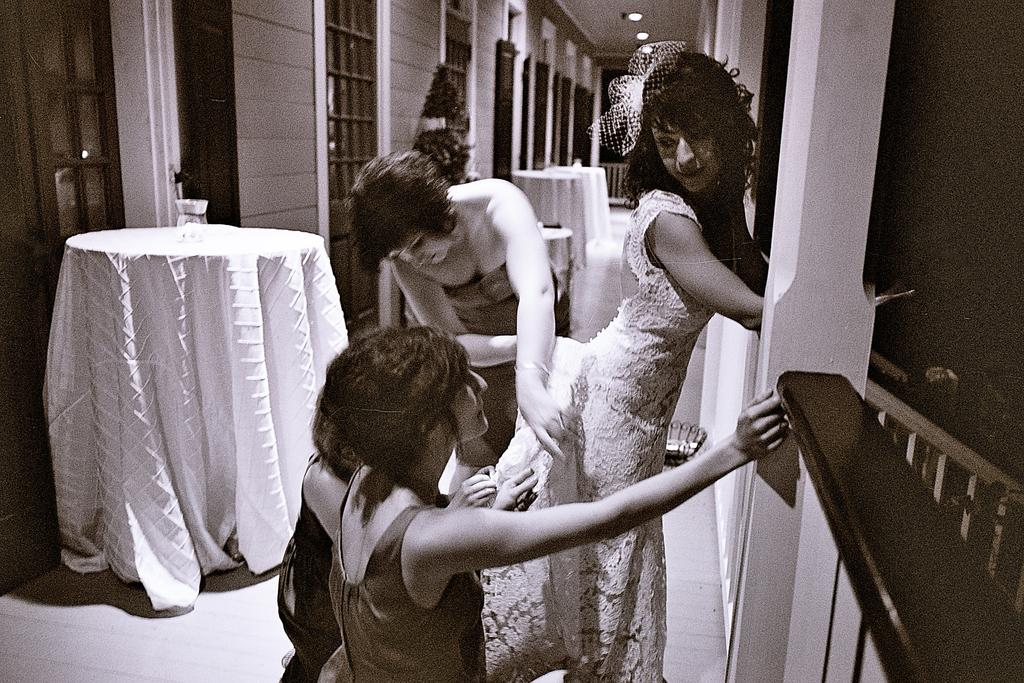What is the color scheme of the image? The image is black and white. How many women are present in the image? There are three women in the image. What can be seen in the middle of the image? There are tables in the middle of the image. What architectural feature is on the right side of the image? There are stairs on the right side of the image. What is visible at the top of the image? There are lights at the top of the image. Where is the desk located in the image? There is no desk present in the image. What type of gate can be seen in the image? There is no gate present in the image. 